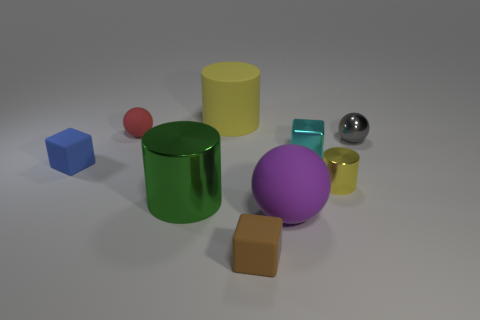The cylinder that is both left of the cyan cube and in front of the metallic sphere is what color?
Give a very brief answer. Green. What number of things are large matte things that are in front of the blue block or large gray rubber cylinders?
Your answer should be very brief. 1. What color is the big thing that is the same shape as the small red matte thing?
Ensure brevity in your answer.  Purple. Does the big purple object have the same shape as the metallic object that is right of the small yellow cylinder?
Your answer should be compact. Yes. What number of things are big yellow rubber things that are to the right of the blue block or large objects behind the gray ball?
Offer a very short reply. 1. Are there fewer yellow objects in front of the big purple rubber object than tiny yellow metal spheres?
Provide a short and direct response. No. Is the tiny gray object made of the same material as the cylinder in front of the small metal cylinder?
Provide a succinct answer. Yes. What is the material of the small blue block?
Provide a short and direct response. Rubber. What material is the yellow thing in front of the sphere that is to the right of the purple rubber thing in front of the large shiny cylinder made of?
Keep it short and to the point. Metal. There is a metallic cube; does it have the same color as the big matte thing that is behind the green thing?
Offer a terse response. No. 